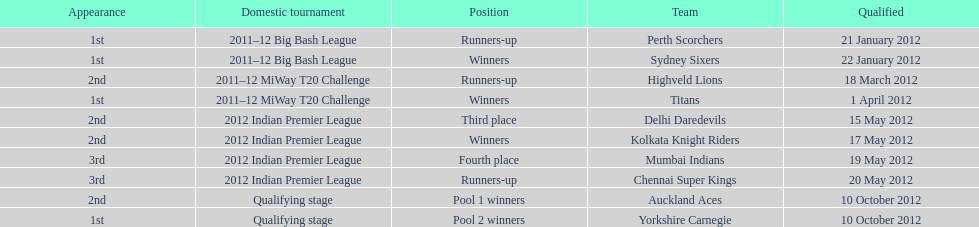What is the total number of teams that qualified? 10. 